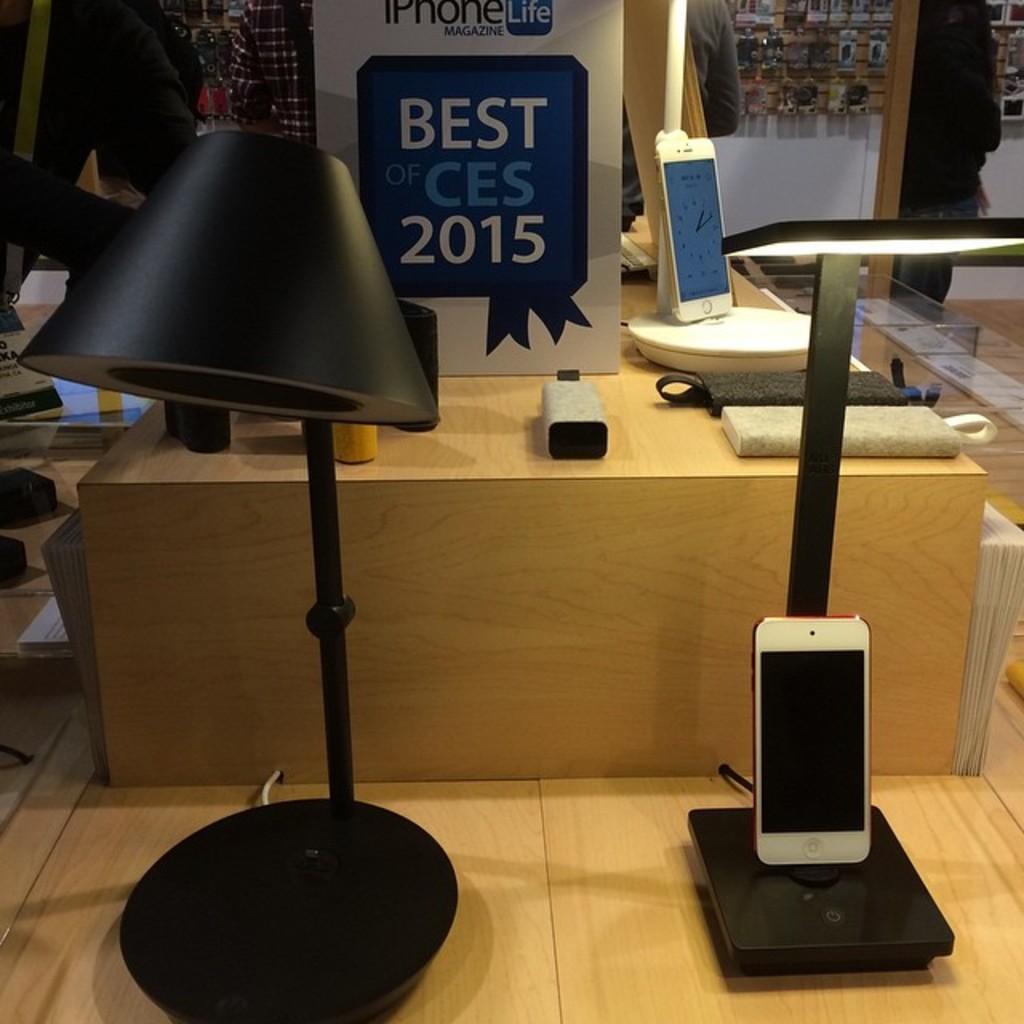Please provide a concise description of this image. In this image we can see mobiles on the stands, objects on the platform, few persons, light, hoarding and in the background we can see objects are hanging on a board on the wall. 